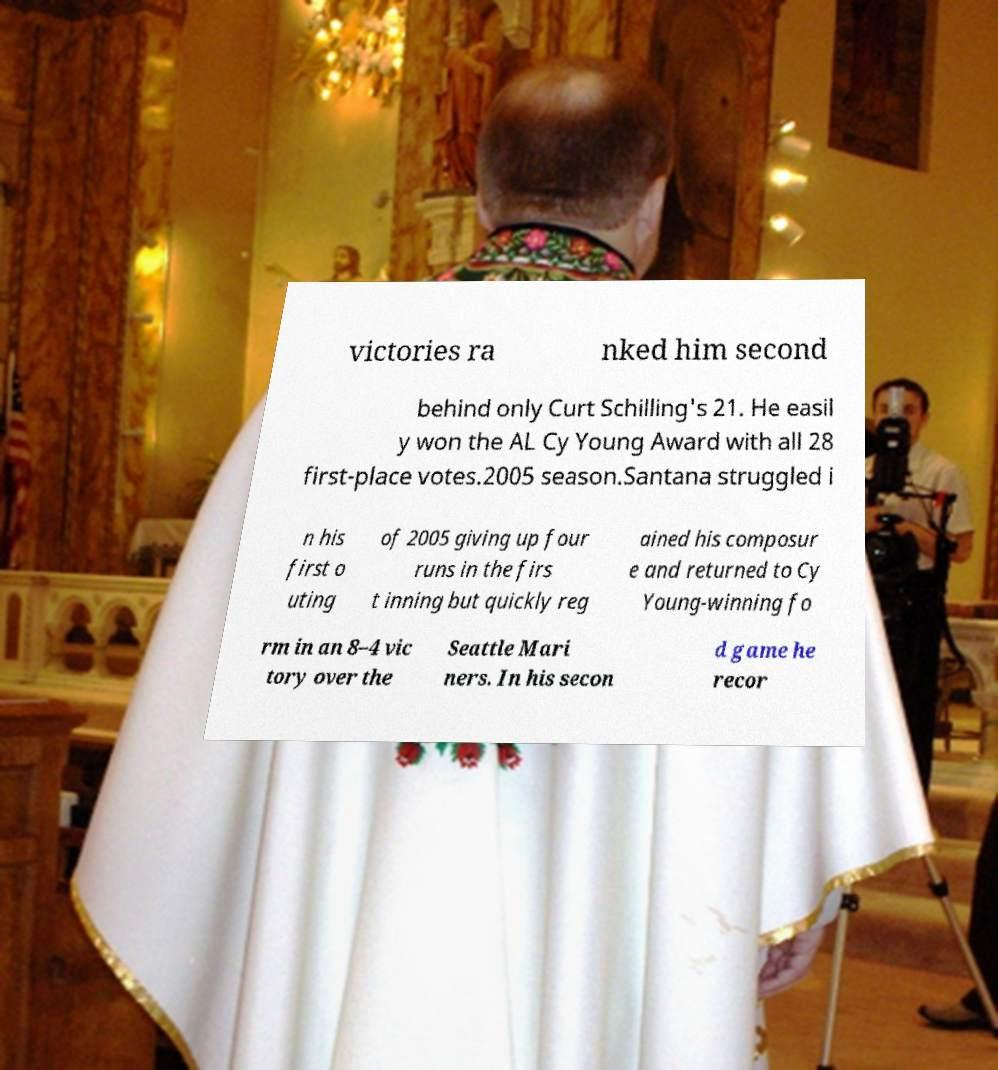Could you assist in decoding the text presented in this image and type it out clearly? victories ra nked him second behind only Curt Schilling's 21. He easil y won the AL Cy Young Award with all 28 first-place votes.2005 season.Santana struggled i n his first o uting of 2005 giving up four runs in the firs t inning but quickly reg ained his composur e and returned to Cy Young-winning fo rm in an 8–4 vic tory over the Seattle Mari ners. In his secon d game he recor 